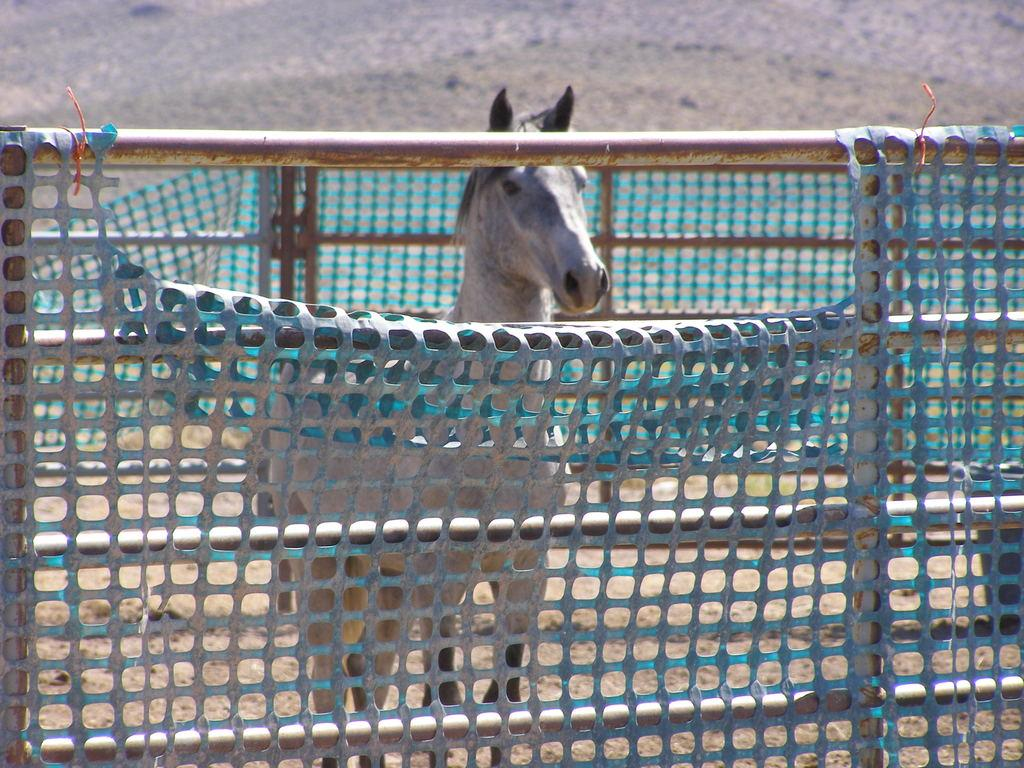What animal can be seen on the ground in the image? There is a horse on the ground in the image. What type of structure is present in the image? There is fencing in the image. Can you describe the composition of the image? There is an object truncated towards the right side of the image. Where is the faucet located in the image? There is no faucet present in the image. 